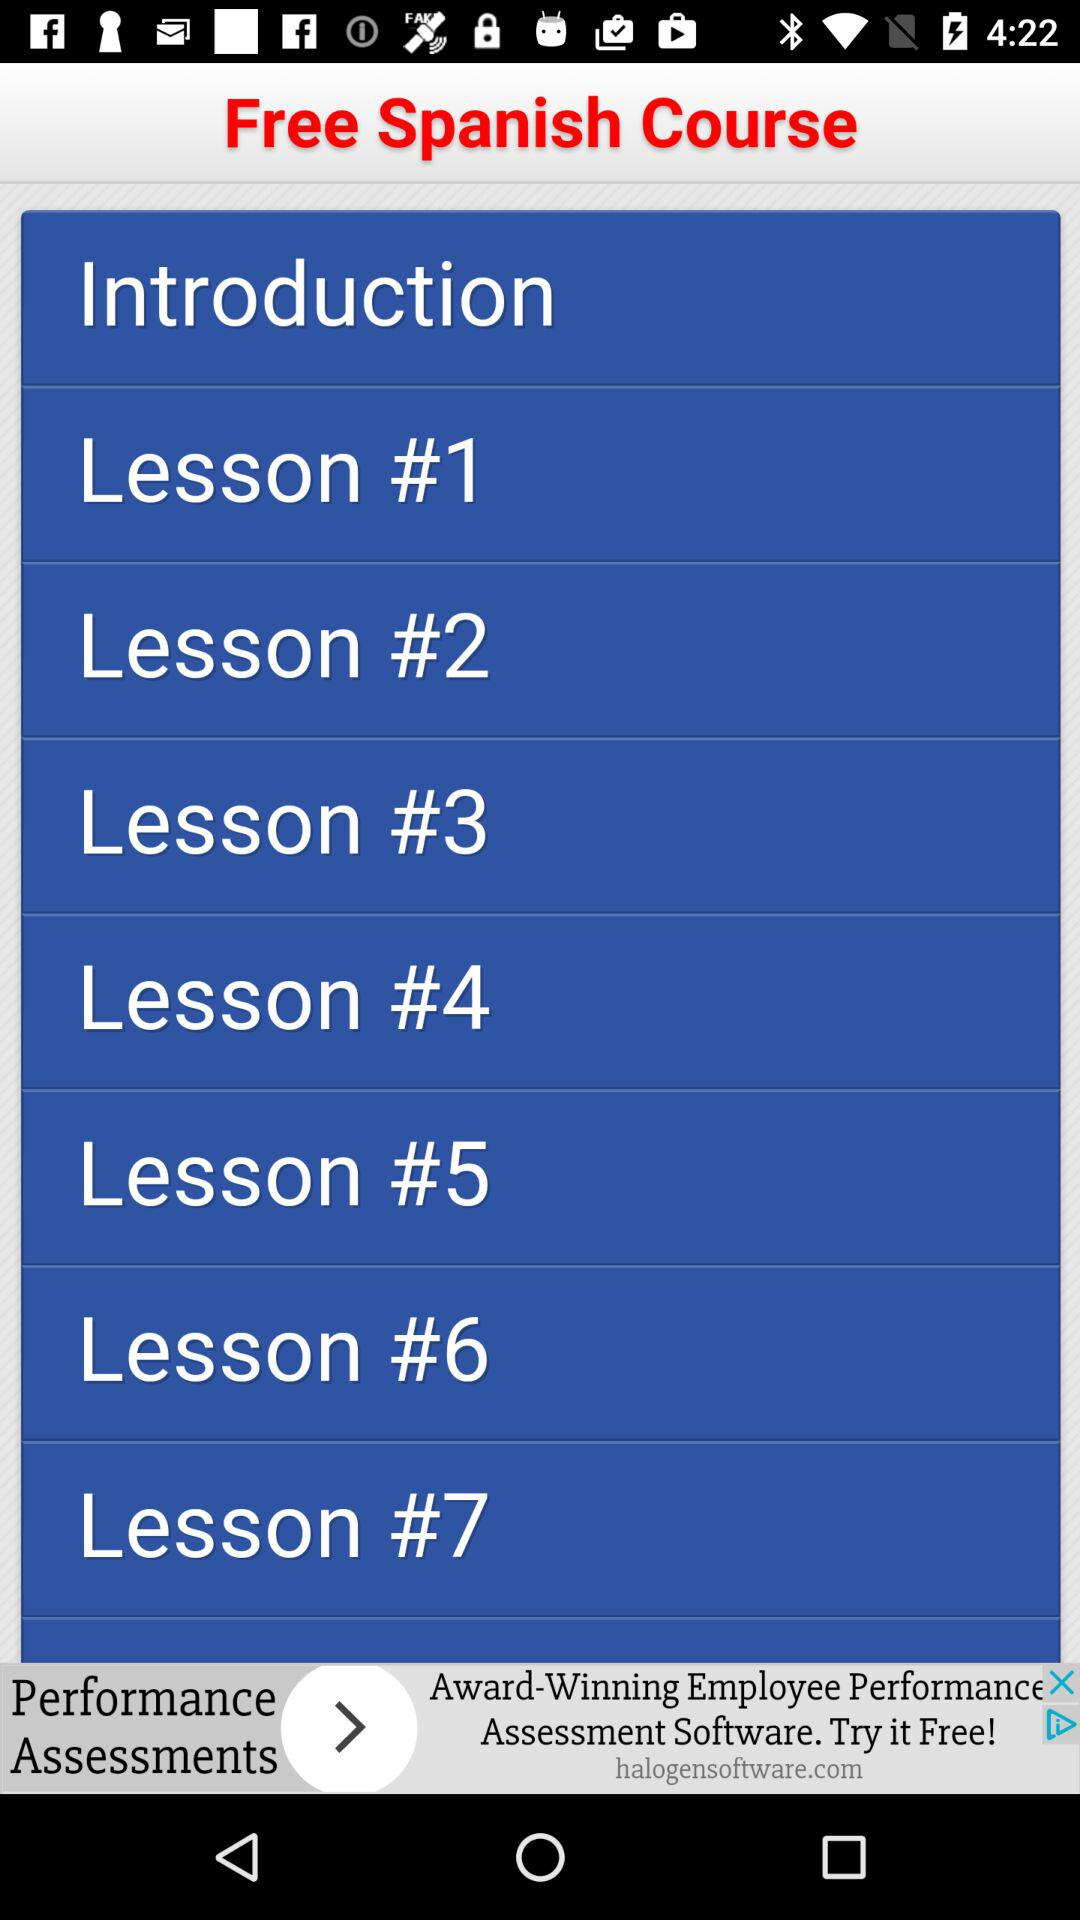Tell me a few contents of the "Free Spanish Course"? The few contents are "Lesson #1", "Lesson #2" and "Lesson #3". 